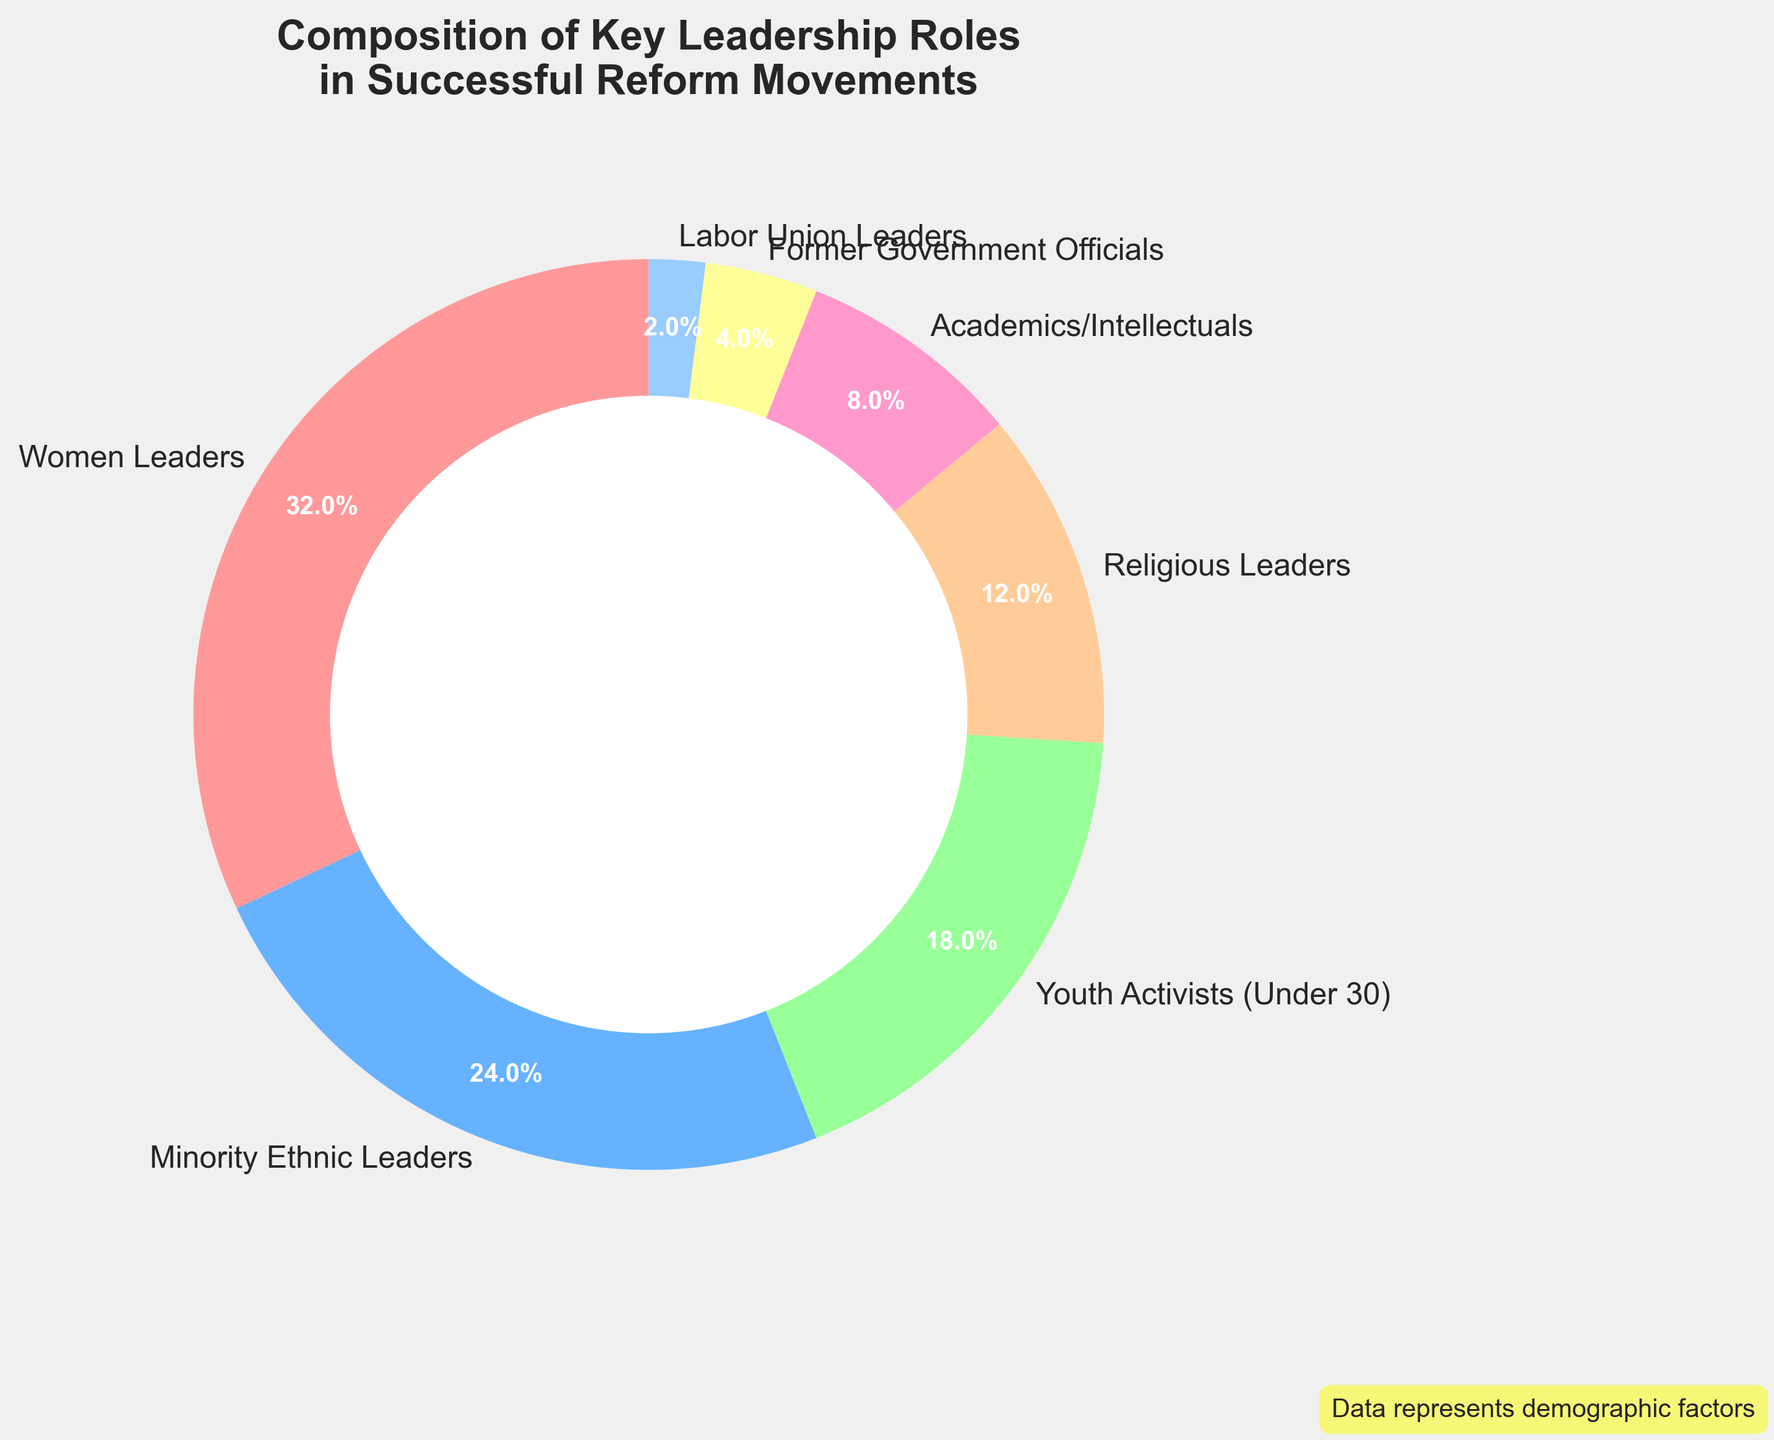What is the sum of the percentages of Women Leaders and Minority Ethnic Leaders? The chart shows that Women Leaders have 32% and Minority Ethnic Leaders have 24%. Summing these percentages: 32% + 24% = 56%
Answer: 56% Which leadership role has the lowest representation? According to the pie chart, Labor Union Leaders have only 2%, making it the lowest representation among all leadership roles shown.
Answer: Labor Union Leaders How does the representation of Youth Activists compare to that of Former Government Officials? Youth Activists (Under 30) have an 18% representation, while Former Government Officials have 4%. Comparing these two, Youth Activists have a higher representation by 18% - 4% = 14%.
Answer: Youth Activists are 14% more represented What percentage of the leadership roles are represented by Religious Leaders and Academics/Intellectuals combined? From the chart, Religious Leaders have 12% and Academics/Intellectuals have 8%. Combined, they account for 12% + 8% = 20%.
Answer: 20% Which demographic has a higher representation: Youth Activists or Academics/Intellectuals, and by how much? Youth Activists are represented at 18% while Academics/Intellectuals are at 8%. To find the difference in their representation: 18% - 8% = 10%.
Answer: Youth Activists by 10% How much more represented are Women Leaders compared to Religious Leaders? From the chart, Women Leaders are at 32% and Religious Leaders are at 12%. The difference in their representation is: 32% - 12% = 20%.
Answer: Women Leaders by 20% What is the average percentage representation of Minority Ethnic Leaders, Youth Activists, and former Government Officials? Minority Ethnic Leaders are at 24%, Youth Activists at 18%, and Former Government Officials at 4%. The average representation is calculated by summing these percentages and dividing by 3: (24% + 18% + 4%) / 3 = 15.33%
Answer: 15.33% Which two groups together make up just under 50% of the representation? Women Leaders have 32% and Minority Ethnic Leaders have 24%. Summing these: 32% + 24% = 56%, which is over 50%. Next, Youth Activists have 18% and Minority Ethnic Leaders have 24%, summing: 18% + 24% = 42%. This pair is just under 50%.
Answer: Youth Activists and Minority Ethnic Leaders What is the most represented leadership role in successful reform movements? The largest segment in the pie chart is the one representing Women Leaders, which has 32%.
Answer: Women Leaders How does the sum of the percentages of Academics/Intellectuals and Labor Union Leaders compare to the representation of Religious Leaders? Academics/Intellectuals are at 8% and Labor Union Leaders are at 2%. Summing these percentages: 8% + 2% = 10%. Comparing to Religious Leaders who are at 12%, 10% is less than 12%.
Answer: Less than 